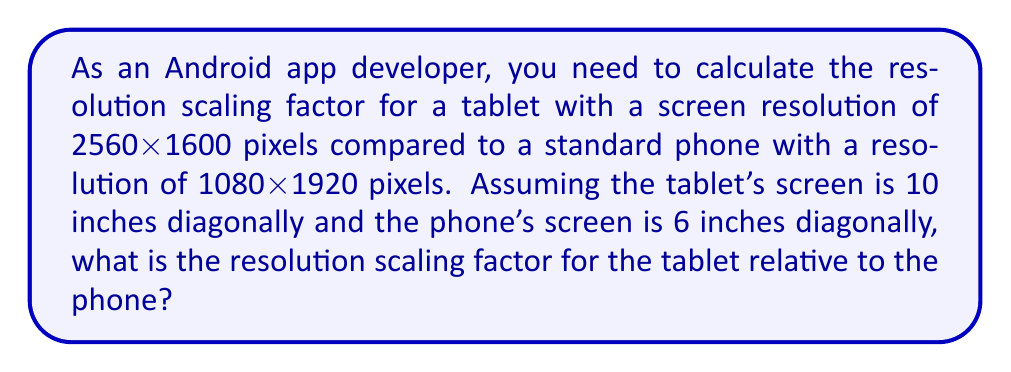Can you answer this question? To calculate the resolution scaling factor, we need to follow these steps:

1. Calculate the pixel density (PPI) for both devices:

   For the tablet:
   $$PPI_{tablet} = \frac{\sqrt{2560^2 + 1600^2}}{10} \approx 299.87$$

   For the phone:
   $$PPI_{phone} = \frac{\sqrt{1080^2 + 1920^2}}{6} \approx 367.84$$

2. Calculate the scaling factor by dividing the tablet's PPI by the phone's PPI:

   $$\text{Scaling factor} = \frac{PPI_{tablet}}{PPI_{phone}} = \frac{299.87}{367.84} \approx 0.8152$$

3. Round the scaling factor to two decimal places:

   $$\text{Scaling factor} \approx 0.82$$

This means that the tablet's screen has about 82% of the pixel density of the phone's screen. To make the app look consistent across both devices, you would need to scale up the UI elements on the tablet by a factor of approximately 1.22 (1 / 0.82) to maintain the same perceived size.
Answer: 0.82 